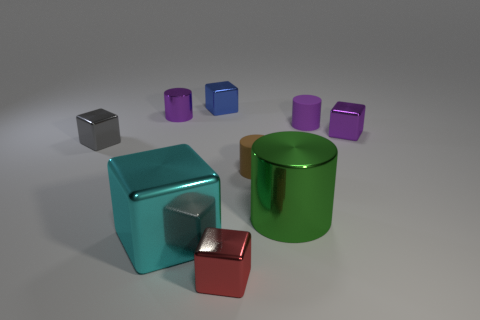Subtract all blue cubes. How many purple cylinders are left? 2 Subtract all tiny blue metal blocks. How many blocks are left? 4 Add 1 cyan metal things. How many objects exist? 10 Subtract all brown cylinders. How many cylinders are left? 3 Subtract 2 cylinders. How many cylinders are left? 2 Subtract all cubes. How many objects are left? 4 Subtract all yellow blocks. Subtract all blue cylinders. How many blocks are left? 5 Add 1 tiny brown things. How many tiny brown things exist? 2 Subtract 0 gray cylinders. How many objects are left? 9 Subtract all small gray metallic things. Subtract all cyan metallic blocks. How many objects are left? 7 